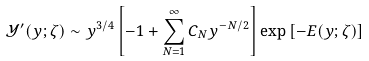Convert formula to latex. <formula><loc_0><loc_0><loc_500><loc_500>{ \mathcal { Y } ^ { \prime } } ( y ; \zeta ) \sim y ^ { 3 / 4 } \left [ - 1 + \sum _ { N = 1 } ^ { \infty } C _ { N } y ^ { - N / 2 } \right ] \exp { [ - E ( y ; \zeta ) ] }</formula> 